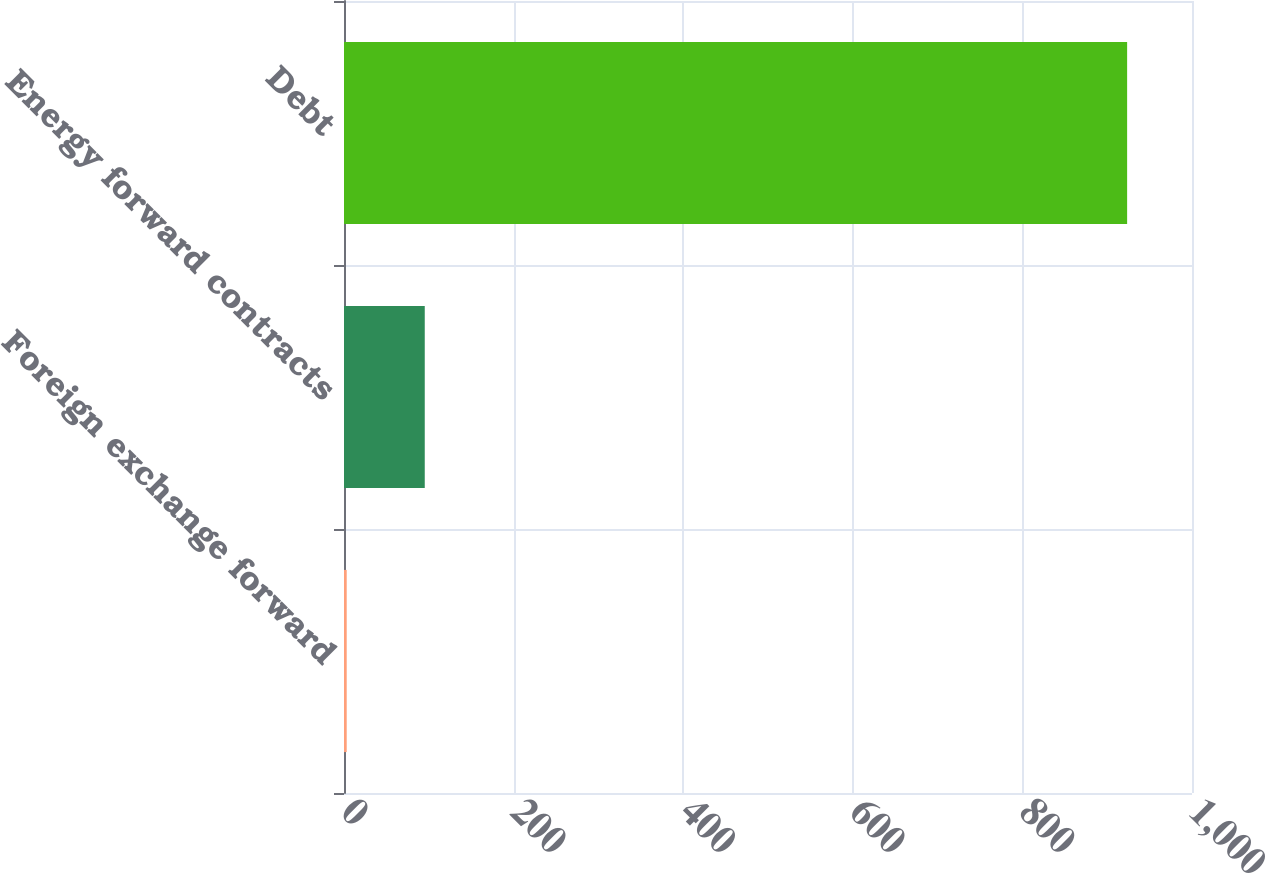<chart> <loc_0><loc_0><loc_500><loc_500><bar_chart><fcel>Foreign exchange forward<fcel>Energy forward contracts<fcel>Debt<nl><fcel>3.2<fcel>95.23<fcel>923.5<nl></chart> 